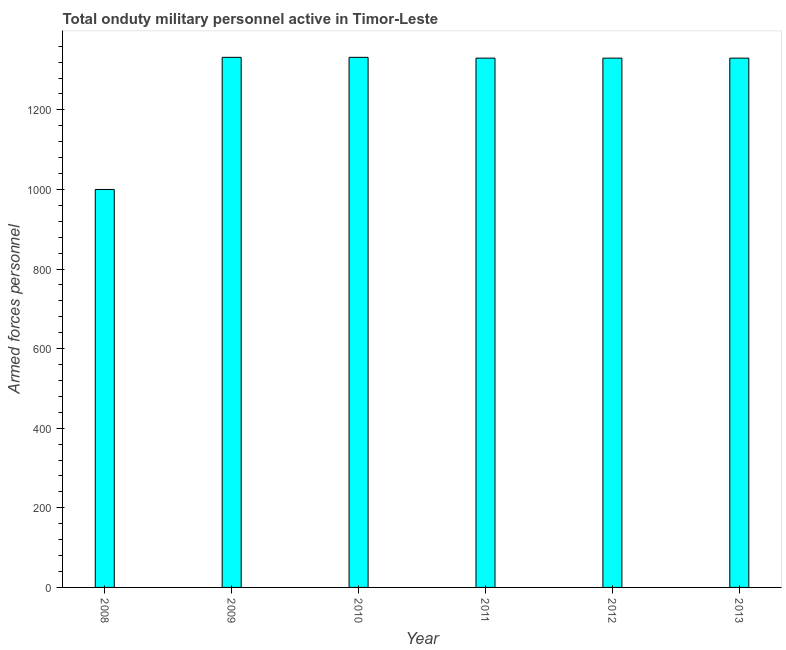Does the graph contain any zero values?
Your answer should be very brief. No. What is the title of the graph?
Provide a short and direct response. Total onduty military personnel active in Timor-Leste. What is the label or title of the Y-axis?
Offer a very short reply. Armed forces personnel. What is the number of armed forces personnel in 2013?
Make the answer very short. 1330. Across all years, what is the maximum number of armed forces personnel?
Make the answer very short. 1332. In which year was the number of armed forces personnel maximum?
Your answer should be very brief. 2009. What is the sum of the number of armed forces personnel?
Provide a short and direct response. 7654. What is the difference between the number of armed forces personnel in 2009 and 2011?
Your response must be concise. 2. What is the average number of armed forces personnel per year?
Your answer should be very brief. 1275. What is the median number of armed forces personnel?
Your answer should be compact. 1330. In how many years, is the number of armed forces personnel greater than 120 ?
Make the answer very short. 6. Do a majority of the years between 2011 and 2012 (inclusive) have number of armed forces personnel greater than 360 ?
Keep it short and to the point. Yes. Is the number of armed forces personnel in 2012 less than that in 2013?
Ensure brevity in your answer.  No. Is the difference between the number of armed forces personnel in 2011 and 2012 greater than the difference between any two years?
Offer a terse response. No. What is the difference between the highest and the second highest number of armed forces personnel?
Offer a very short reply. 0. Is the sum of the number of armed forces personnel in 2008 and 2013 greater than the maximum number of armed forces personnel across all years?
Your answer should be very brief. Yes. What is the difference between the highest and the lowest number of armed forces personnel?
Offer a terse response. 332. Are the values on the major ticks of Y-axis written in scientific E-notation?
Provide a short and direct response. No. What is the Armed forces personnel in 2008?
Provide a short and direct response. 1000. What is the Armed forces personnel in 2009?
Give a very brief answer. 1332. What is the Armed forces personnel of 2010?
Provide a succinct answer. 1332. What is the Armed forces personnel of 2011?
Your answer should be compact. 1330. What is the Armed forces personnel in 2012?
Keep it short and to the point. 1330. What is the Armed forces personnel in 2013?
Your answer should be very brief. 1330. What is the difference between the Armed forces personnel in 2008 and 2009?
Make the answer very short. -332. What is the difference between the Armed forces personnel in 2008 and 2010?
Offer a terse response. -332. What is the difference between the Armed forces personnel in 2008 and 2011?
Your response must be concise. -330. What is the difference between the Armed forces personnel in 2008 and 2012?
Offer a terse response. -330. What is the difference between the Armed forces personnel in 2008 and 2013?
Keep it short and to the point. -330. What is the difference between the Armed forces personnel in 2009 and 2012?
Provide a succinct answer. 2. What is the difference between the Armed forces personnel in 2011 and 2012?
Make the answer very short. 0. What is the difference between the Armed forces personnel in 2011 and 2013?
Ensure brevity in your answer.  0. What is the difference between the Armed forces personnel in 2012 and 2013?
Your answer should be compact. 0. What is the ratio of the Armed forces personnel in 2008 to that in 2009?
Offer a very short reply. 0.75. What is the ratio of the Armed forces personnel in 2008 to that in 2010?
Your answer should be very brief. 0.75. What is the ratio of the Armed forces personnel in 2008 to that in 2011?
Ensure brevity in your answer.  0.75. What is the ratio of the Armed forces personnel in 2008 to that in 2012?
Offer a terse response. 0.75. What is the ratio of the Armed forces personnel in 2008 to that in 2013?
Your answer should be very brief. 0.75. What is the ratio of the Armed forces personnel in 2009 to that in 2010?
Make the answer very short. 1. What is the ratio of the Armed forces personnel in 2009 to that in 2013?
Offer a terse response. 1. What is the ratio of the Armed forces personnel in 2010 to that in 2012?
Offer a very short reply. 1. What is the ratio of the Armed forces personnel in 2010 to that in 2013?
Ensure brevity in your answer.  1. 